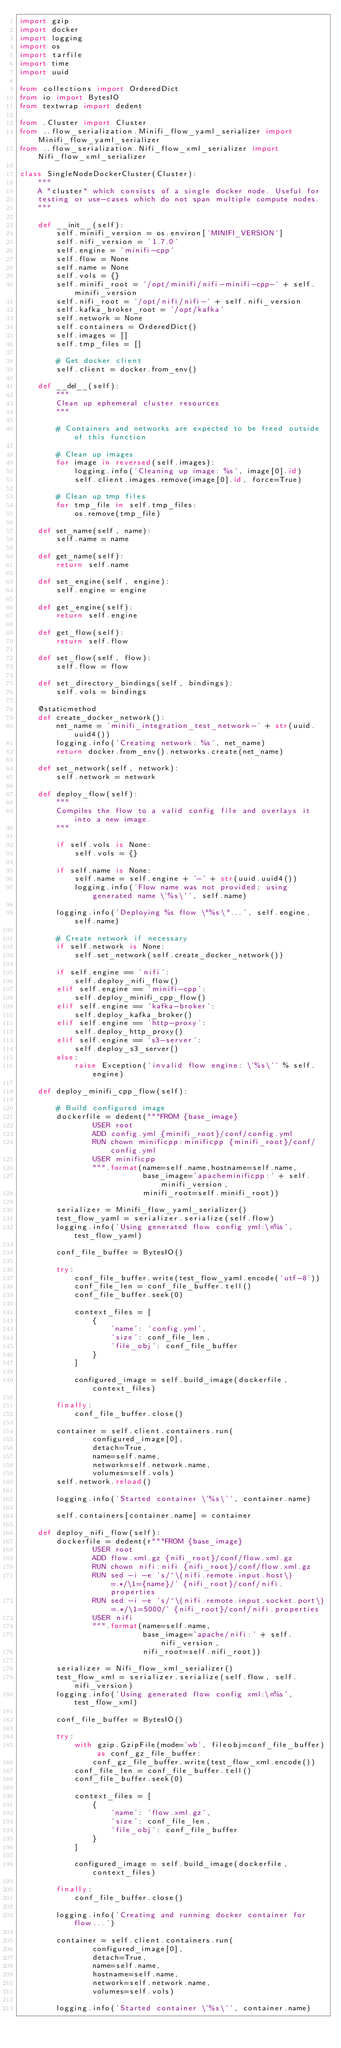<code> <loc_0><loc_0><loc_500><loc_500><_Python_>import gzip
import docker
import logging
import os
import tarfile
import time
import uuid

from collections import OrderedDict
from io import BytesIO
from textwrap import dedent

from .Cluster import Cluster
from ..flow_serialization.Minifi_flow_yaml_serializer import Minifi_flow_yaml_serializer
from ..flow_serialization.Nifi_flow_xml_serializer import Nifi_flow_xml_serializer

class SingleNodeDockerCluster(Cluster):
    """
    A "cluster" which consists of a single docker node. Useful for
    testing or use-cases which do not span multiple compute nodes.
    """

    def __init__(self):
        self.minifi_version = os.environ['MINIFI_VERSION']
        self.nifi_version = '1.7.0'
        self.engine = 'minifi-cpp'
        self.flow = None
        self.name = None
        self.vols = {}
        self.minifi_root = '/opt/minifi/nifi-minifi-cpp-' + self.minifi_version
        self.nifi_root = '/opt/nifi/nifi-' + self.nifi_version
        self.kafka_broker_root = '/opt/kafka'
        self.network = None
        self.containers = OrderedDict()
        self.images = []
        self.tmp_files = []

        # Get docker client
        self.client = docker.from_env()

    def __del__(self):
        """
        Clean up ephemeral cluster resources
        """

        # Containers and networks are expected to be freed outside of this function

        # Clean up images
        for image in reversed(self.images):
            logging.info('Cleaning up image: %s', image[0].id)
            self.client.images.remove(image[0].id, force=True)

        # Clean up tmp files
        for tmp_file in self.tmp_files:
            os.remove(tmp_file)

    def set_name(self, name):
        self.name = name

    def get_name(self):
        return self.name

    def set_engine(self, engine):
        self.engine = engine

    def get_engine(self):
        return self.engine

    def get_flow(self):
        return self.flow

    def set_flow(self, flow):
        self.flow = flow

    def set_directory_bindings(self, bindings):
        self.vols = bindings

    @staticmethod
    def create_docker_network():
        net_name = 'minifi_integration_test_network-' + str(uuid.uuid4())
        logging.info('Creating network: %s', net_name)
        return docker.from_env().networks.create(net_name)

    def set_network(self, network):
        self.network = network

    def deploy_flow(self):
        """
        Compiles the flow to a valid config file and overlays it into a new image.
        """

        if self.vols is None:
            self.vols = {}

        if self.name is None:
            self.name = self.engine + '-' + str(uuid.uuid4())
            logging.info('Flow name was not provided; using generated name \'%s\'', self.name)

        logging.info('Deploying %s flow \"%s\"...', self.engine, self.name)

        # Create network if necessary
        if self.network is None:
            self.set_network(self.create_docker_network())

        if self.engine == 'nifi':
            self.deploy_nifi_flow()
        elif self.engine == 'minifi-cpp':
            self.deploy_minifi_cpp_flow()
        elif self.engine == 'kafka-broker':
            self.deploy_kafka_broker()
        elif self.engine == 'http-proxy':
            self.deploy_http_proxy()
        elif self.engine == 's3-server':
            self.deploy_s3_server()
        else:
            raise Exception('invalid flow engine: \'%s\'' % self.engine)

    def deploy_minifi_cpp_flow(self):

        # Build configured image
        dockerfile = dedent("""FROM {base_image}
                USER root
                ADD config.yml {minifi_root}/conf/config.yml
                RUN chown minificpp:minificpp {minifi_root}/conf/config.yml
                USER minificpp
                """.format(name=self.name,hostname=self.name,
                           base_image='apacheminificpp:' + self.minifi_version,
                           minifi_root=self.minifi_root))

        serializer = Minifi_flow_yaml_serializer()
        test_flow_yaml = serializer.serialize(self.flow)
        logging.info('Using generated flow config yml:\n%s', test_flow_yaml)

        conf_file_buffer = BytesIO()

        try:
            conf_file_buffer.write(test_flow_yaml.encode('utf-8'))
            conf_file_len = conf_file_buffer.tell()
            conf_file_buffer.seek(0)

            context_files = [
                {
                    'name': 'config.yml',
                    'size': conf_file_len,
                    'file_obj': conf_file_buffer
                }
            ]

            configured_image = self.build_image(dockerfile, context_files)

        finally:
            conf_file_buffer.close()

        container = self.client.containers.run(
                configured_image[0],
                detach=True,
                name=self.name,
                network=self.network.name,
                volumes=self.vols)
        self.network.reload()

        logging.info('Started container \'%s\'', container.name)

        self.containers[container.name] = container

    def deploy_nifi_flow(self):
        dockerfile = dedent(r"""FROM {base_image}
                USER root
                ADD flow.xml.gz {nifi_root}/conf/flow.xml.gz
                RUN chown nifi:nifi {nifi_root}/conf/flow.xml.gz
                RUN sed -i -e 's/^\(nifi.remote.input.host\)=.*/\1={name}/' {nifi_root}/conf/nifi.properties
                RUN sed -i -e 's/^\(nifi.remote.input.socket.port\)=.*/\1=5000/' {nifi_root}/conf/nifi.properties
                USER nifi
                """.format(name=self.name,
                           base_image='apache/nifi:' + self.nifi_version,
                           nifi_root=self.nifi_root))

        serializer = Nifi_flow_xml_serializer()
        test_flow_xml = serializer.serialize(self.flow, self.nifi_version)
        logging.info('Using generated flow config xml:\n%s', test_flow_xml)

        conf_file_buffer = BytesIO()

        try:
            with gzip.GzipFile(mode='wb', fileobj=conf_file_buffer) as conf_gz_file_buffer:
                conf_gz_file_buffer.write(test_flow_xml.encode())
            conf_file_len = conf_file_buffer.tell()
            conf_file_buffer.seek(0)

            context_files = [
                {
                    'name': 'flow.xml.gz',
                    'size': conf_file_len,
                    'file_obj': conf_file_buffer
                }
            ]

            configured_image = self.build_image(dockerfile, context_files)

        finally:
            conf_file_buffer.close()

        logging.info('Creating and running docker container for flow...')

        container = self.client.containers.run(
                configured_image[0],
                detach=True,
                name=self.name,
                hostname=self.name,
                network=self.network.name,
                volumes=self.vols)

        logging.info('Started container \'%s\'', container.name)
</code> 